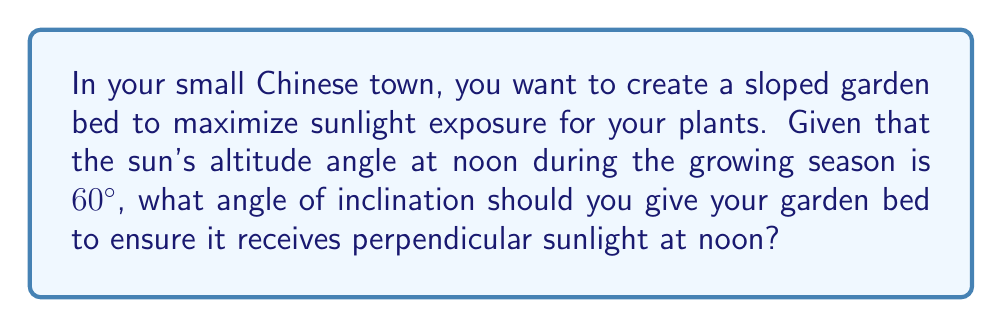Show me your answer to this math problem. Let's approach this step-by-step:

1) For maximum sunlight exposure, we want the garden bed to be perpendicular to the sun's rays at noon, when the sun is at its highest point.

2) We're given that the sun's altitude angle (angle above the horizon) at noon is 60°.

3) Let's visualize this with a diagram:

[asy]
import geometry;

size(200);
pair O=(0,0), A=(2,0), B=(2,sqrt(3));
draw(O--A--B--O);
draw(A--(2,-0.5),dashed);
label("Ground", (1,-0.3), S);
label("Sun's rays", (2.3,sqrt(3)/2), E);
label("Garden bed", (1,sqrt(3)/4), NW);
label("60°", (0.3,0), N);
label("θ", (1.7,0), S);

markangle(A,O,B,radius=0.5);
markangle(O,A,B,radius=0.3);
</asy]

4) In this diagram:
   - The ground is represented by the horizontal line
   - The sun's rays are coming in at a 60° angle from the ground
   - The garden bed is represented by the hypotenuse of the triangle
   - θ represents the angle we're trying to find

5) For the garden bed to be perpendicular to the sun's rays, it must form a right angle (90°) with the sun's rays.

6) In a right triangle, the sum of all angles is 180°. We know two angles:
   - The angle between the ground and sun's rays (60°)
   - The right angle between the sun's rays and garden bed (90°)

7) Let's call our unknown angle θ. We can set up an equation:

   $$60° + 90° + θ = 180°$$

8) Solving for θ:
   $$θ = 180° - (60° + 90°) = 180° - 150° = 30°$$

Therefore, the garden bed should be inclined at a 30° angle from the ground.
Answer: 30° 